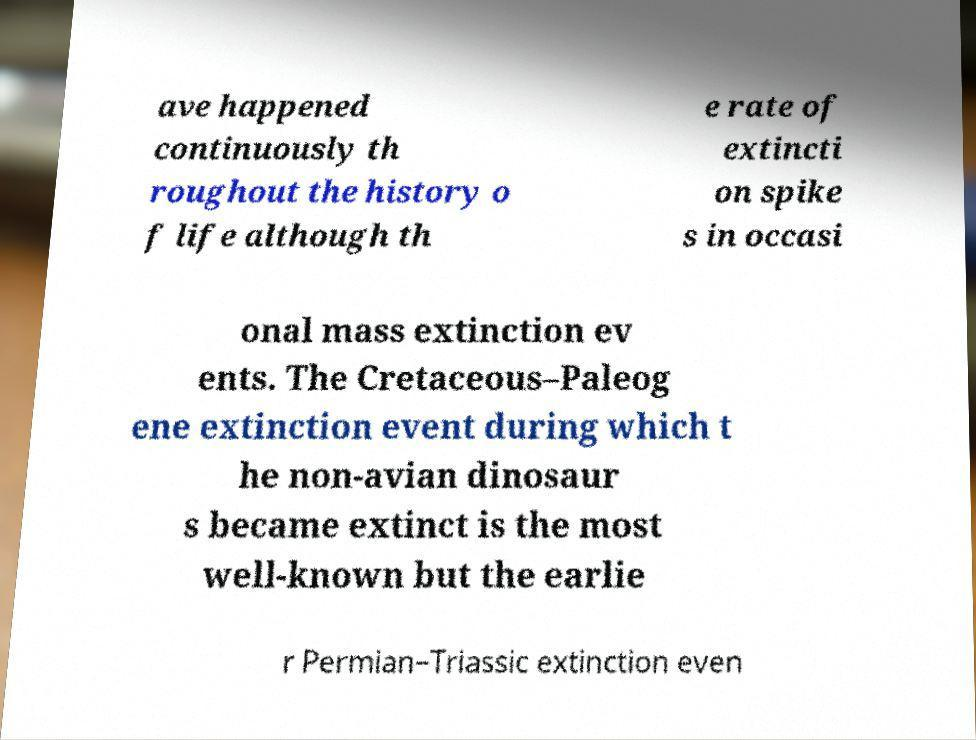Can you read and provide the text displayed in the image?This photo seems to have some interesting text. Can you extract and type it out for me? ave happened continuously th roughout the history o f life although th e rate of extincti on spike s in occasi onal mass extinction ev ents. The Cretaceous–Paleog ene extinction event during which t he non-avian dinosaur s became extinct is the most well-known but the earlie r Permian–Triassic extinction even 